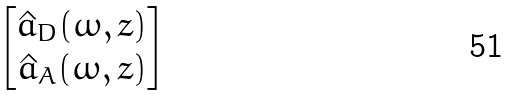<formula> <loc_0><loc_0><loc_500><loc_500>\begin{bmatrix} \hat { a } _ { D } ( \omega , z ) \\ \hat { a } _ { A } ( \omega , z ) \end{bmatrix}</formula> 